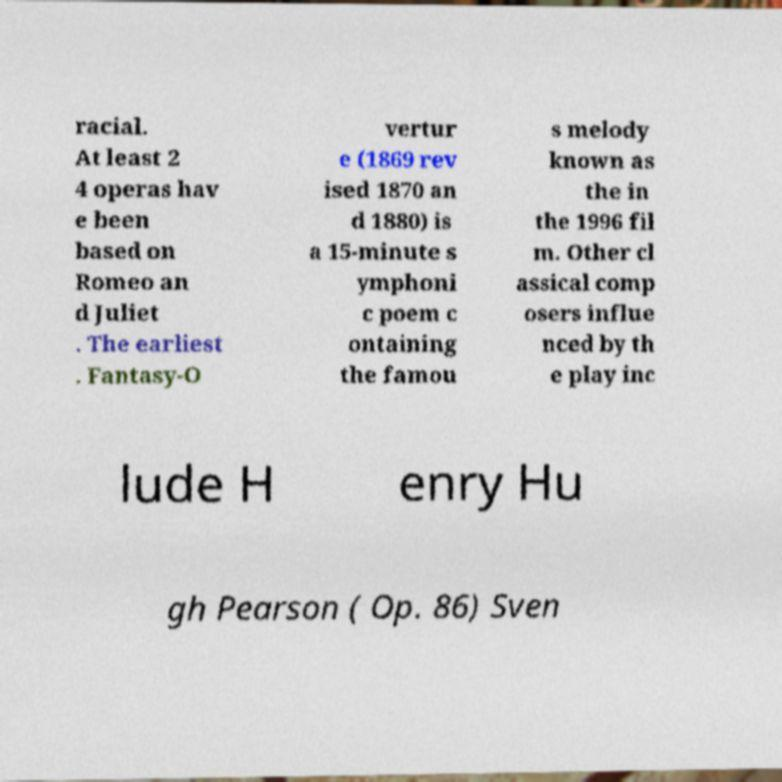Can you accurately transcribe the text from the provided image for me? racial. At least 2 4 operas hav e been based on Romeo an d Juliet . The earliest . Fantasy-O vertur e (1869 rev ised 1870 an d 1880) is a 15-minute s ymphoni c poem c ontaining the famou s melody known as the in the 1996 fil m. Other cl assical comp osers influe nced by th e play inc lude H enry Hu gh Pearson ( Op. 86) Sven 